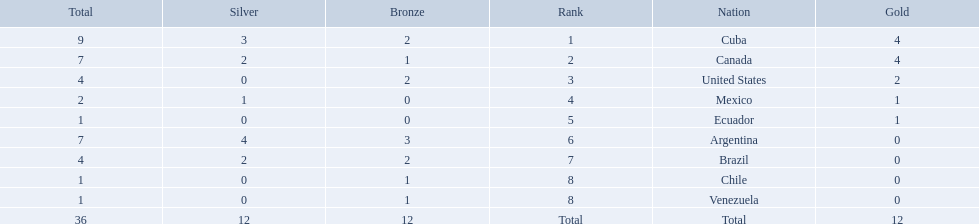What were the amounts of bronze medals won by the countries? 2, 1, 2, 0, 0, 3, 2, 1, 1. Which is the highest? 3. Which nation had this amount? Argentina. What countries participated? Cuba, 4, 3, 2, Canada, 4, 2, 1, United States, 2, 0, 2, Mexico, 1, 1, 0, Ecuador, 1, 0, 0, Argentina, 0, 4, 3, Brazil, 0, 2, 2, Chile, 0, 0, 1, Venezuela, 0, 0, 1. What countries won 1 gold Mexico, 1, 1, 0, Ecuador, 1, 0, 0. What country above also won no silver? Ecuador. Which nations won gold medals? Cuba, Canada, United States, Mexico, Ecuador. How many medals did each nation win? Cuba, 9, Canada, 7, United States, 4, Mexico, 2, Ecuador, 1. Which nation only won a gold medal? Ecuador. 